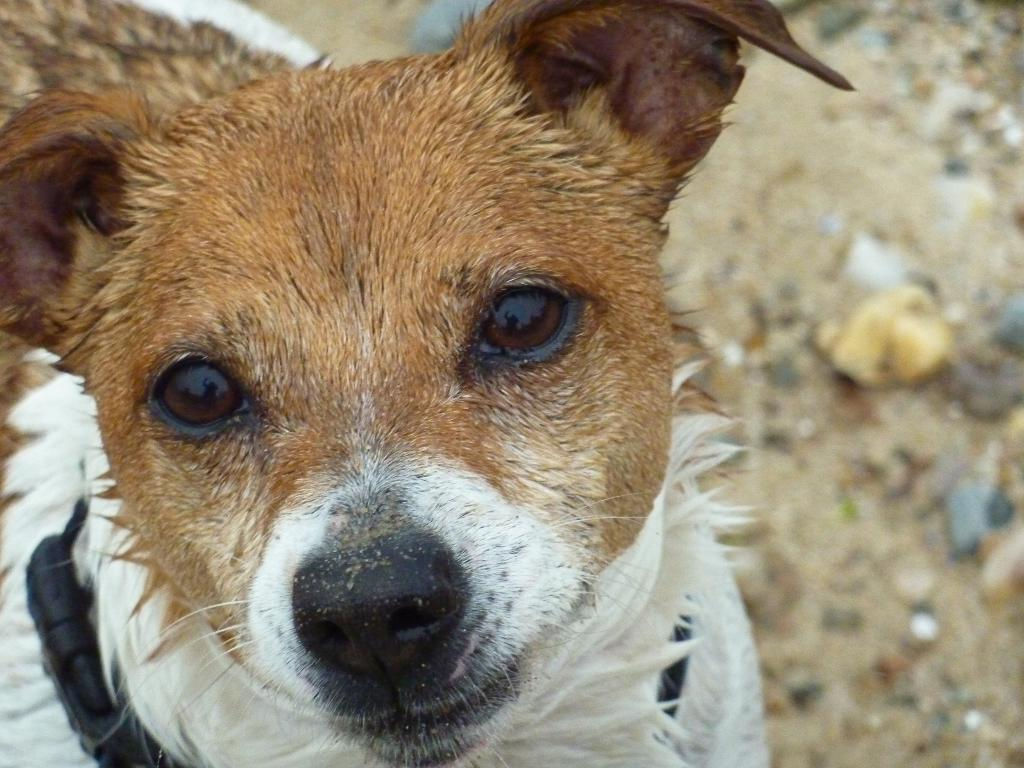What animal is present in the image? There is a dog in the image. What is the dog doing in the image? The dog is watching something. Can you describe the background of the image? The background of the image has a blurred view. What is visible on the right side of the image? There is ground visible on the right side of the image. What type of knife is the dog holding in its hands in the image? There is no knife or hands visible in the image; it features a dog watching something with a blurred background. 